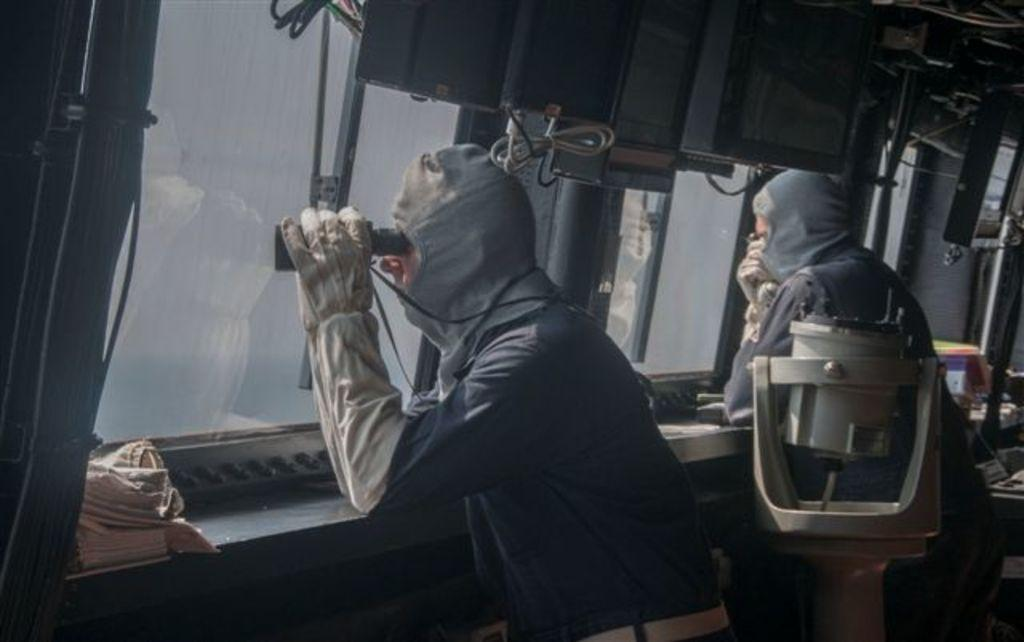How many people are in the image? There are two persons in the image. What are the persons doing in the image? The persons are standing in a vehicle. What object is one person holding in the image? One person is holding a binocular. What action is the person with the binocular performing? They are looking through the binocular. What type of owl can be seen sitting on the oatmeal in the image? There is no owl or oatmeal present in the image; it features two persons standing in a vehicle with one person holding a binocular. 